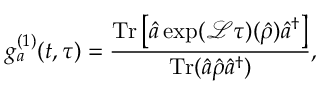<formula> <loc_0><loc_0><loc_500><loc_500>g _ { a } ^ { ( 1 ) } ( t , \tau ) = \frac { T r \left [ \hat { a } \exp ( \mathcal { L } \tau ) ( \hat { \rho } ) \hat { a } ^ { \dagger } \right ] } { T r ( \hat { a } \hat { \rho } \hat { a } ^ { \dagger } ) } ,</formula> 